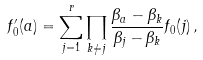Convert formula to latex. <formula><loc_0><loc_0><loc_500><loc_500>f ^ { \prime } _ { 0 } ( a ) = \sum ^ { r } _ { j = 1 } \prod _ { k \neq j } \frac { \beta _ { a } - \beta _ { k } } { \beta _ { j } - \beta _ { k } } f _ { 0 } ( j ) \, ,</formula> 